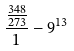Convert formula to latex. <formula><loc_0><loc_0><loc_500><loc_500>\frac { \frac { 3 4 8 } { 2 7 3 } } { 1 } - 9 ^ { 1 3 }</formula> 